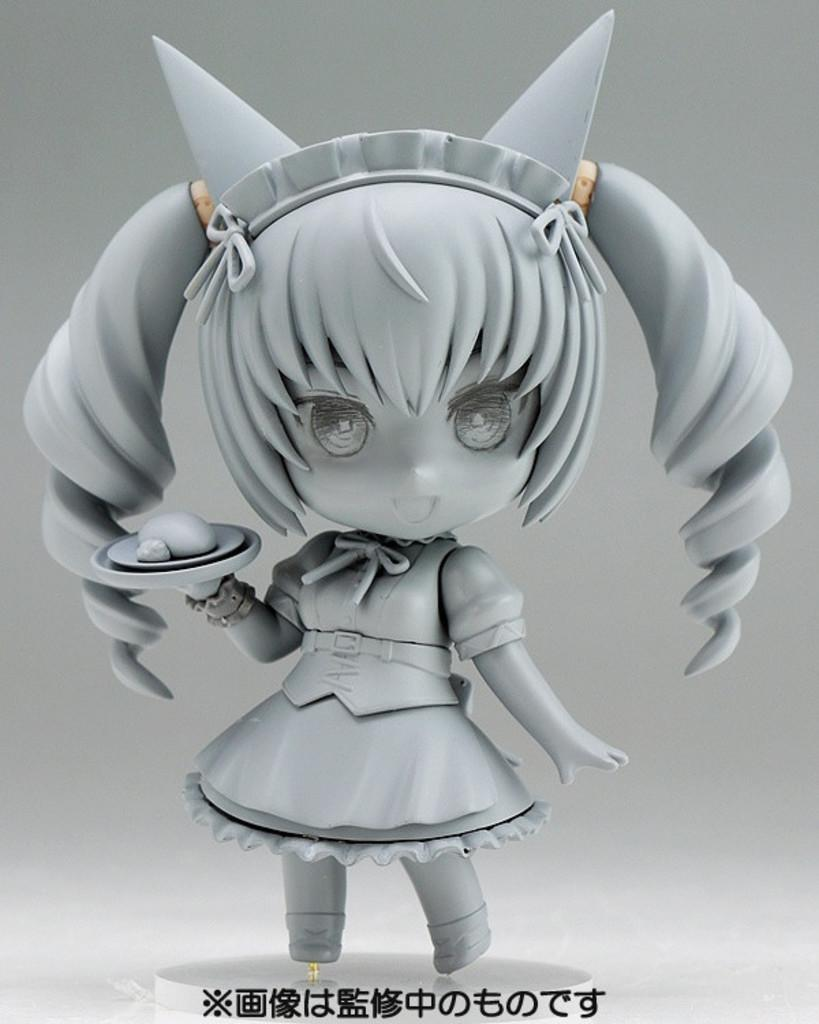What is the main subject in the middle of the image? There is a toy in the middle of the image. What can be found at the bottom of the image? There is text at the bottom of the image. What type of sound does the lamp make in the image? There is no lamp present in the image, so it is not possible to determine what sound it might make. 